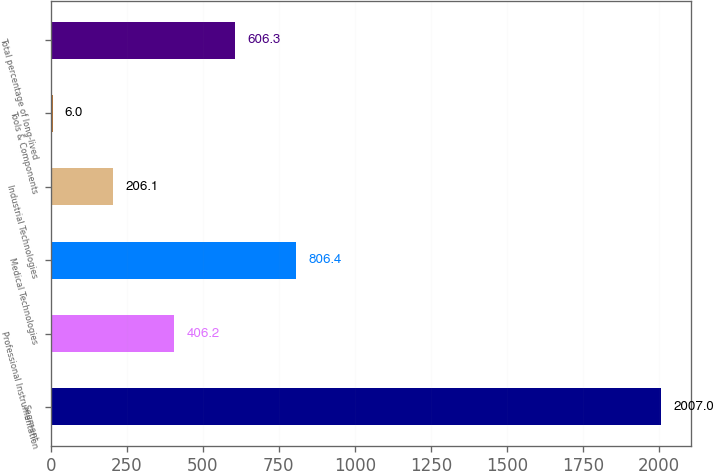Convert chart to OTSL. <chart><loc_0><loc_0><loc_500><loc_500><bar_chart><fcel>Segment<fcel>Professional Instrumentation<fcel>Medical Technologies<fcel>Industrial Technologies<fcel>Tools & Components<fcel>Total percentage of long-lived<nl><fcel>2007<fcel>406.2<fcel>806.4<fcel>206.1<fcel>6<fcel>606.3<nl></chart> 